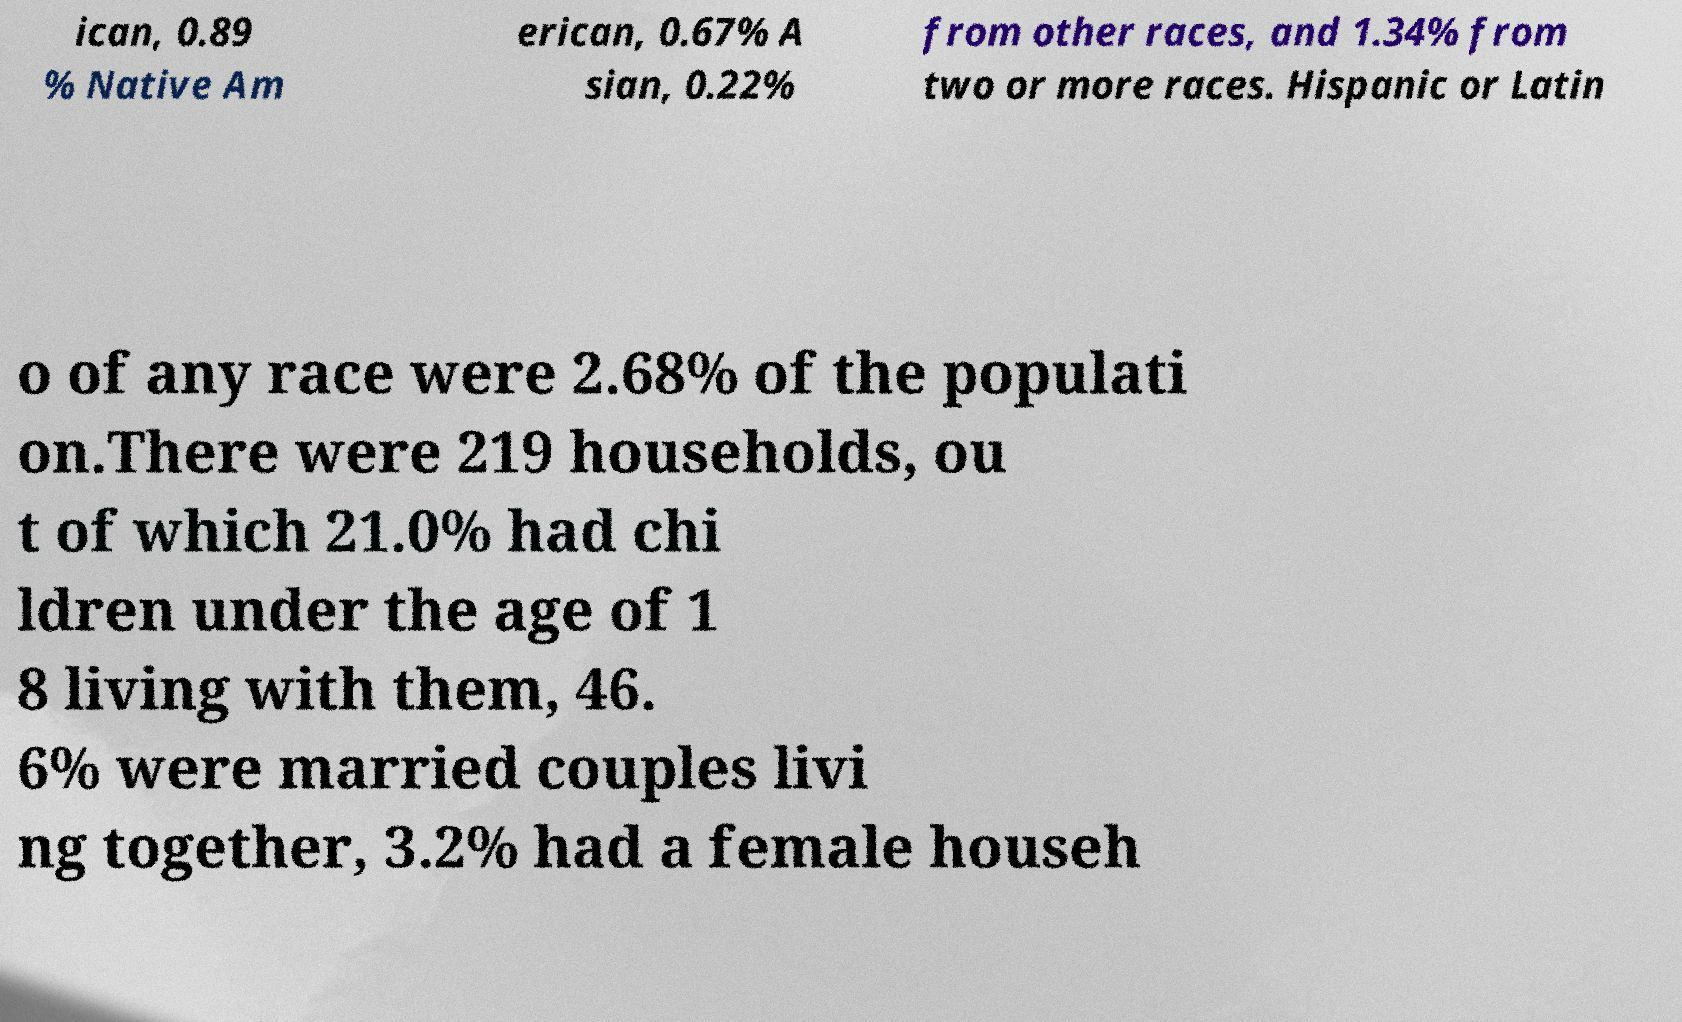Please identify and transcribe the text found in this image. ican, 0.89 % Native Am erican, 0.67% A sian, 0.22% from other races, and 1.34% from two or more races. Hispanic or Latin o of any race were 2.68% of the populati on.There were 219 households, ou t of which 21.0% had chi ldren under the age of 1 8 living with them, 46. 6% were married couples livi ng together, 3.2% had a female househ 